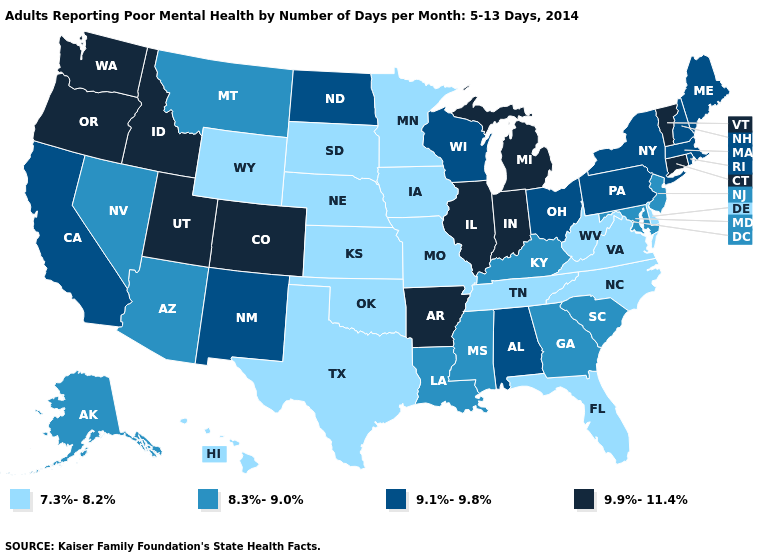What is the value of Rhode Island?
Be succinct. 9.1%-9.8%. Name the states that have a value in the range 8.3%-9.0%?
Write a very short answer. Alaska, Arizona, Georgia, Kentucky, Louisiana, Maryland, Mississippi, Montana, Nevada, New Jersey, South Carolina. Name the states that have a value in the range 9.1%-9.8%?
Quick response, please. Alabama, California, Maine, Massachusetts, New Hampshire, New Mexico, New York, North Dakota, Ohio, Pennsylvania, Rhode Island, Wisconsin. What is the highest value in states that border Delaware?
Write a very short answer. 9.1%-9.8%. What is the value of Idaho?
Concise answer only. 9.9%-11.4%. Name the states that have a value in the range 8.3%-9.0%?
Give a very brief answer. Alaska, Arizona, Georgia, Kentucky, Louisiana, Maryland, Mississippi, Montana, Nevada, New Jersey, South Carolina. What is the highest value in the West ?
Write a very short answer. 9.9%-11.4%. What is the value of Wyoming?
Quick response, please. 7.3%-8.2%. What is the value of New Hampshire?
Short answer required. 9.1%-9.8%. Among the states that border Idaho , which have the highest value?
Concise answer only. Oregon, Utah, Washington. Does Ohio have the highest value in the USA?
Give a very brief answer. No. Which states have the highest value in the USA?
Be succinct. Arkansas, Colorado, Connecticut, Idaho, Illinois, Indiana, Michigan, Oregon, Utah, Vermont, Washington. Name the states that have a value in the range 7.3%-8.2%?
Keep it brief. Delaware, Florida, Hawaii, Iowa, Kansas, Minnesota, Missouri, Nebraska, North Carolina, Oklahoma, South Dakota, Tennessee, Texas, Virginia, West Virginia, Wyoming. What is the highest value in states that border Maine?
Quick response, please. 9.1%-9.8%. How many symbols are there in the legend?
Write a very short answer. 4. 